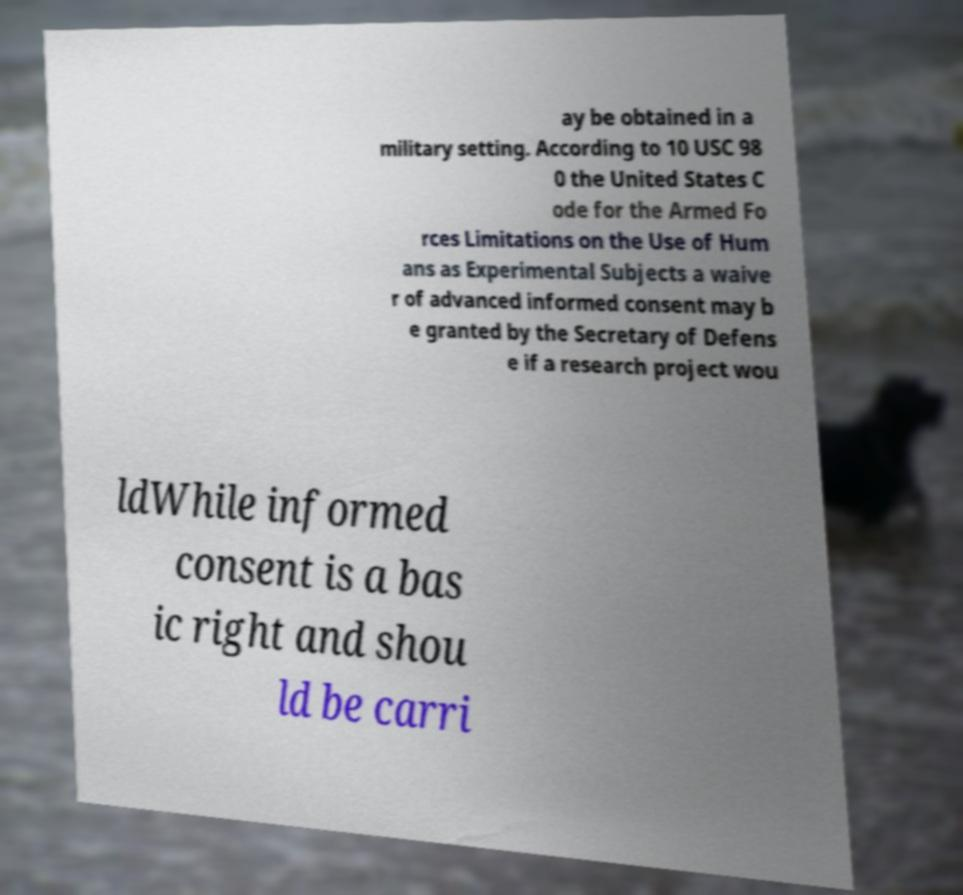Please identify and transcribe the text found in this image. ay be obtained in a military setting. According to 10 USC 98 0 the United States C ode for the Armed Fo rces Limitations on the Use of Hum ans as Experimental Subjects a waive r of advanced informed consent may b e granted by the Secretary of Defens e if a research project wou ldWhile informed consent is a bas ic right and shou ld be carri 